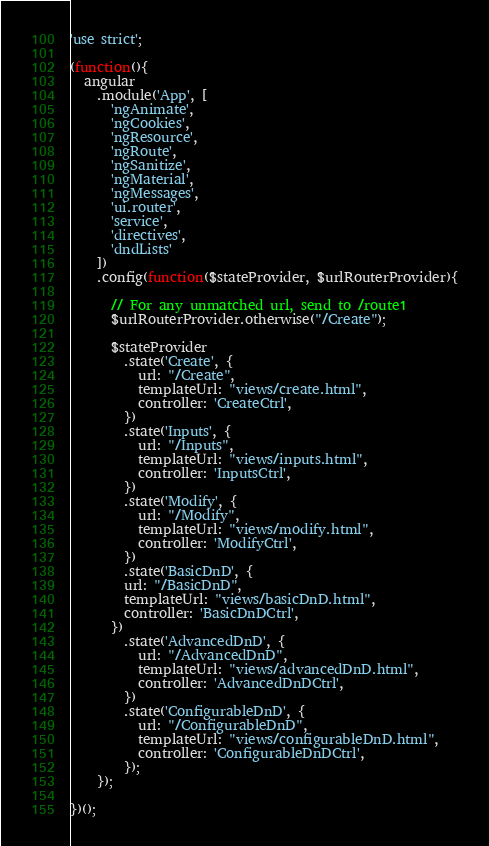Convert code to text. <code><loc_0><loc_0><loc_500><loc_500><_JavaScript_>'use strict';

(function(){
  angular
    .module('App', [
      'ngAnimate',
      'ngCookies',
      'ngResource',
      'ngRoute',
      'ngSanitize',
      'ngMaterial',
      'ngMessages',
      'ui.router',
      'service',
      'directives',
      'dndLists'
    ])
    .config(function($stateProvider, $urlRouterProvider){

      // For any unmatched url, send to /route1
      $urlRouterProvider.otherwise("/Create");

      $stateProvider
        .state('Create', {
          url: "/Create",
          templateUrl: "views/create.html",
          controller: 'CreateCtrl',
        })
        .state('Inputs', {
          url: "/Inputs",
          templateUrl: "views/inputs.html",
          controller: 'InputsCtrl',
        })
        .state('Modify', {
          url: "/Modify",
          templateUrl: "views/modify.html",
          controller: 'ModifyCtrl',
        }) 
        .state('BasicDnD', {
        url: "/BasicDnD",
        templateUrl: "views/basicDnD.html",
        controller: 'BasicDnDCtrl',
      })
        .state('AdvancedDnD', {
          url: "/AdvancedDnD",
          templateUrl: "views/advancedDnD.html",
          controller: 'AdvancedDnDCtrl',
        })
        .state('ConfigurableDnD', {
          url: "/ConfigurableDnD",
          templateUrl: "views/configurableDnD.html",
          controller: 'ConfigurableDnDCtrl',
        });
    });

})();
</code> 